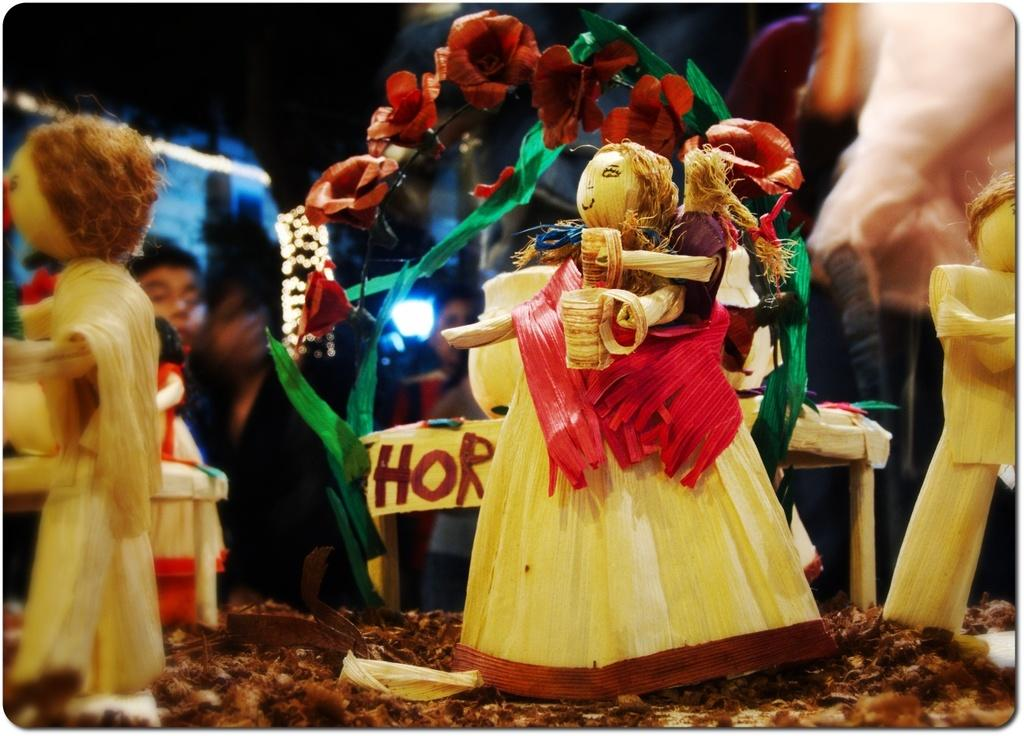What is placed on the floor in the image? There are idols on the floor in the image. Can you describe the background of the image? There are humans visible in the background of the image. How many beds are visible in the image? There are no beds present in the image. What type of basin can be seen in the image? There is no basin present in the image. 